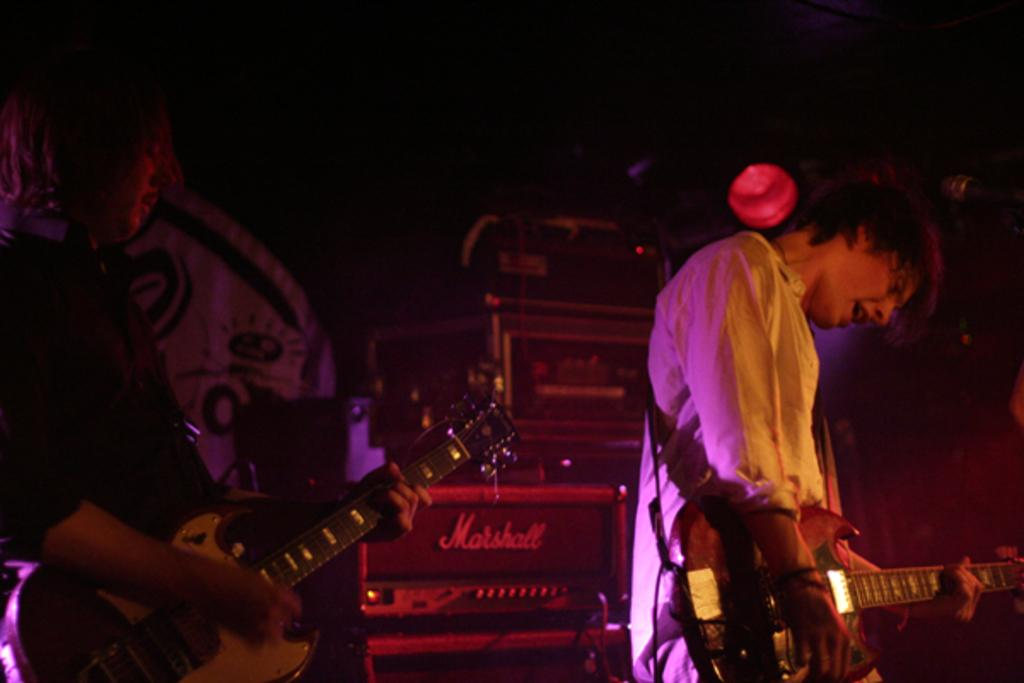How many people are in the image? There are two people in the image. What are the people doing in the image? The people are playing musical instruments. What can be seen in the background of the image? There are boxes visible in the background. Can you describe any other objects or features in the image? Yes, there is a curtain and a light in the image. What position does the spy hold in the image? There is no spy present in the image. How many crates are visible in the image? There are no crates visible in the image. 